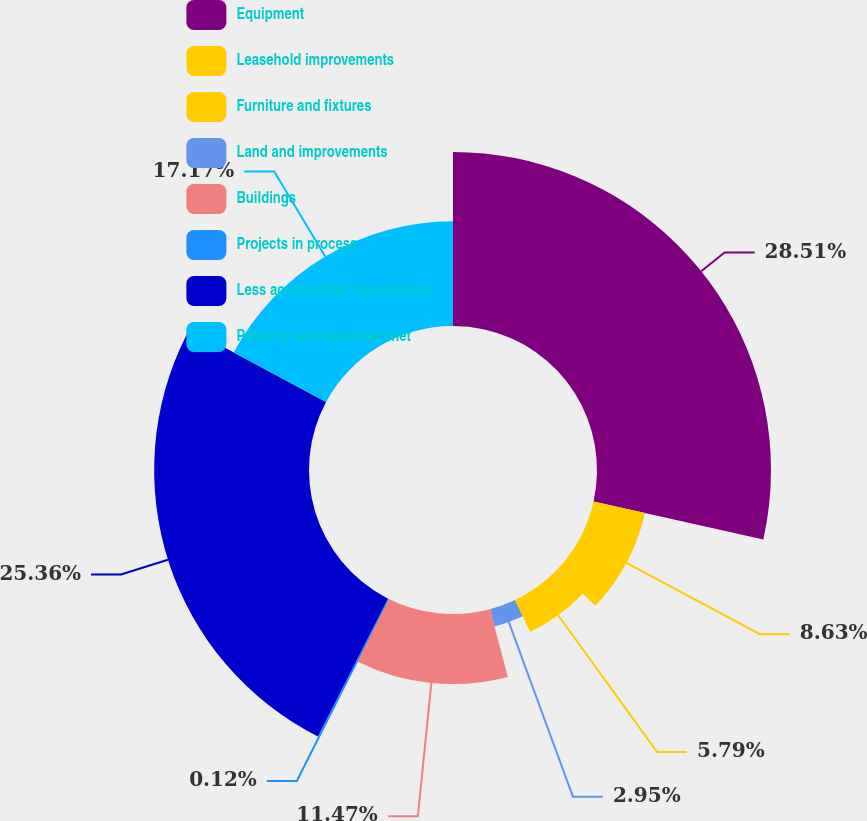<chart> <loc_0><loc_0><loc_500><loc_500><pie_chart><fcel>Equipment<fcel>Leasehold improvements<fcel>Furniture and fixtures<fcel>Land and improvements<fcel>Buildings<fcel>Projects in process<fcel>Less accumulated depreciation<fcel>Property and equipment net<nl><fcel>28.5%<fcel>8.63%<fcel>5.79%<fcel>2.95%<fcel>11.47%<fcel>0.12%<fcel>25.36%<fcel>17.17%<nl></chart> 